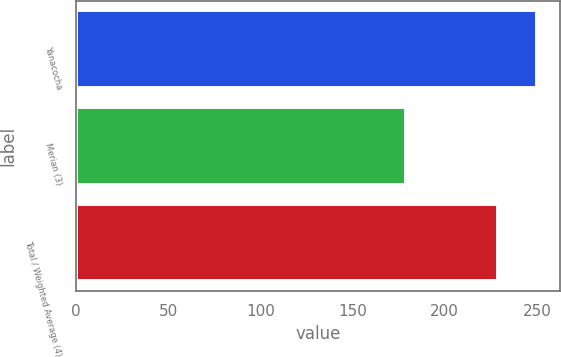<chart> <loc_0><loc_0><loc_500><loc_500><bar_chart><fcel>Yanacocha<fcel>Merian (3)<fcel>Total / Weighted Average (4)<nl><fcel>250<fcel>179<fcel>229<nl></chart> 